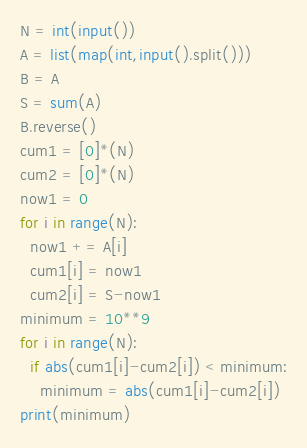<code> <loc_0><loc_0><loc_500><loc_500><_Python_>N = int(input())
A = list(map(int,input().split()))
B = A
S = sum(A)
B.reverse()
cum1 = [0]*(N)
cum2 = [0]*(N)
now1 = 0
for i in range(N):
  now1 += A[i]
  cum1[i] = now1
  cum2[i] = S-now1
minimum = 10**9
for i in range(N):
  if abs(cum1[i]-cum2[i]) < minimum:
    minimum = abs(cum1[i]-cum2[i])
print(minimum)
</code> 